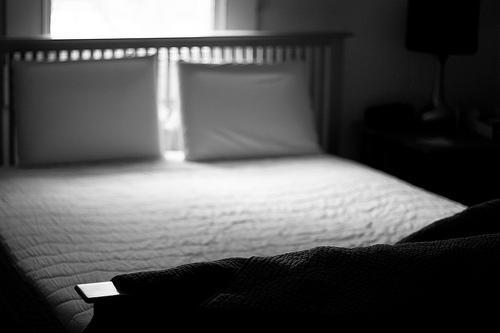How many pillows are there?
Give a very brief answer. 2. 